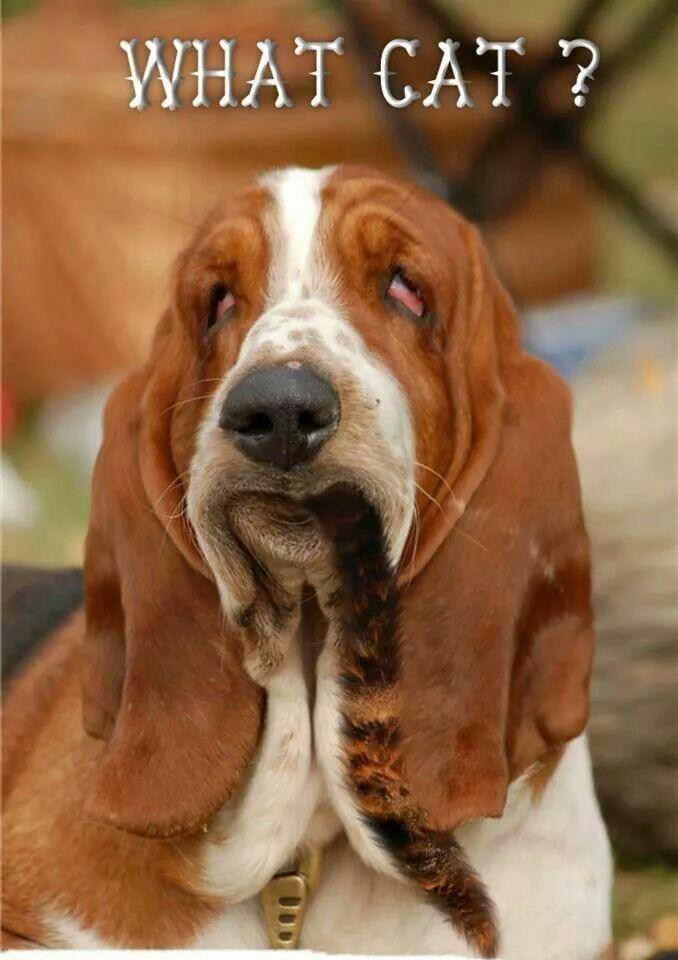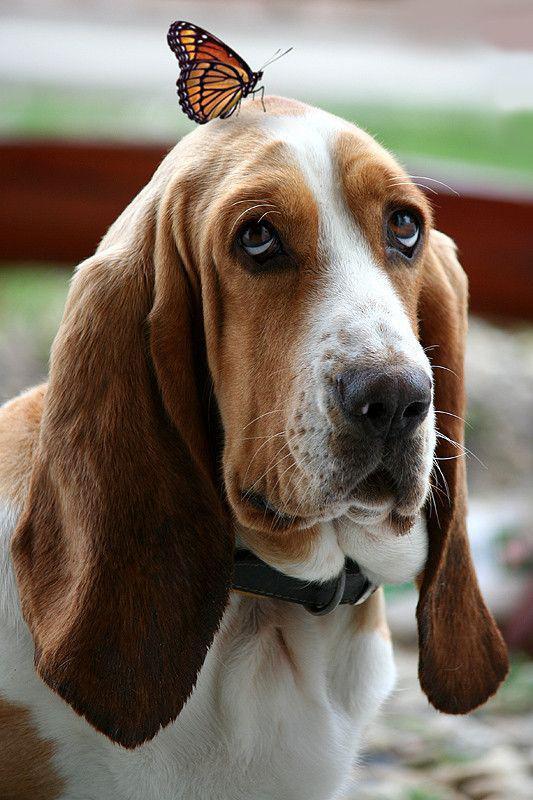The first image is the image on the left, the second image is the image on the right. Assess this claim about the two images: "At least one image contains a human being.". Correct or not? Answer yes or no. No. The first image is the image on the left, the second image is the image on the right. Evaluate the accuracy of this statement regarding the images: "There is a droopy dog being held by a person in one image, and a droopy dog with no person in the other.". Is it true? Answer yes or no. No. 